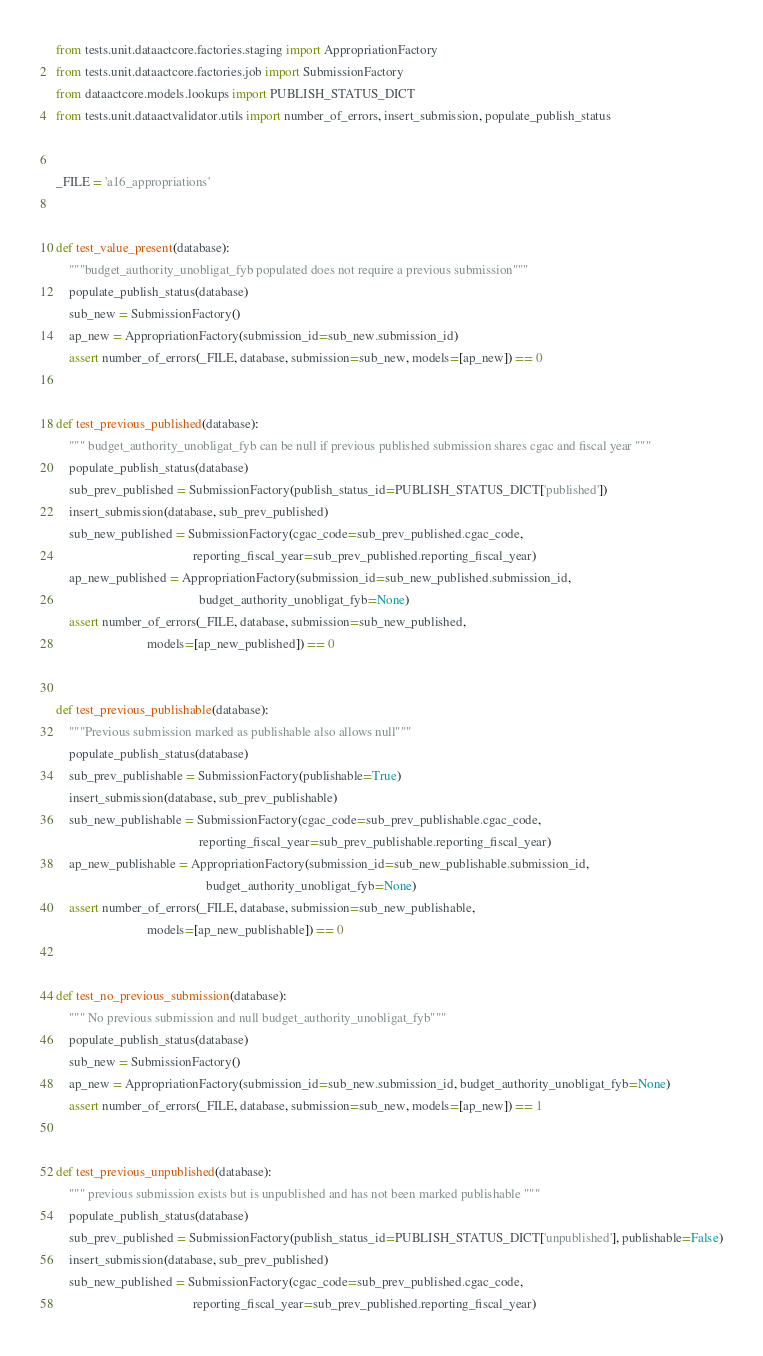<code> <loc_0><loc_0><loc_500><loc_500><_Python_>from tests.unit.dataactcore.factories.staging import AppropriationFactory
from tests.unit.dataactcore.factories.job import SubmissionFactory
from dataactcore.models.lookups import PUBLISH_STATUS_DICT
from tests.unit.dataactvalidator.utils import number_of_errors, insert_submission, populate_publish_status


_FILE = 'a16_appropriations'


def test_value_present(database):
    """budget_authority_unobligat_fyb populated does not require a previous submission"""
    populate_publish_status(database)
    sub_new = SubmissionFactory()
    ap_new = AppropriationFactory(submission_id=sub_new.submission_id)
    assert number_of_errors(_FILE, database, submission=sub_new, models=[ap_new]) == 0


def test_previous_published(database):
    """ budget_authority_unobligat_fyb can be null if previous published submission shares cgac and fiscal year """
    populate_publish_status(database)
    sub_prev_published = SubmissionFactory(publish_status_id=PUBLISH_STATUS_DICT['published'])
    insert_submission(database, sub_prev_published)
    sub_new_published = SubmissionFactory(cgac_code=sub_prev_published.cgac_code,
                                          reporting_fiscal_year=sub_prev_published.reporting_fiscal_year)
    ap_new_published = AppropriationFactory(submission_id=sub_new_published.submission_id,
                                            budget_authority_unobligat_fyb=None)
    assert number_of_errors(_FILE, database, submission=sub_new_published,
                            models=[ap_new_published]) == 0


def test_previous_publishable(database):
    """Previous submission marked as publishable also allows null"""
    populate_publish_status(database)
    sub_prev_publishable = SubmissionFactory(publishable=True)
    insert_submission(database, sub_prev_publishable)
    sub_new_publishable = SubmissionFactory(cgac_code=sub_prev_publishable.cgac_code,
                                            reporting_fiscal_year=sub_prev_publishable.reporting_fiscal_year)
    ap_new_publishable = AppropriationFactory(submission_id=sub_new_publishable.submission_id,
                                              budget_authority_unobligat_fyb=None)
    assert number_of_errors(_FILE, database, submission=sub_new_publishable,
                            models=[ap_new_publishable]) == 0


def test_no_previous_submission(database):
    """ No previous submission and null budget_authority_unobligat_fyb"""
    populate_publish_status(database)
    sub_new = SubmissionFactory()
    ap_new = AppropriationFactory(submission_id=sub_new.submission_id, budget_authority_unobligat_fyb=None)
    assert number_of_errors(_FILE, database, submission=sub_new, models=[ap_new]) == 1


def test_previous_unpublished(database):
    """ previous submission exists but is unpublished and has not been marked publishable """
    populate_publish_status(database)
    sub_prev_published = SubmissionFactory(publish_status_id=PUBLISH_STATUS_DICT['unpublished'], publishable=False)
    insert_submission(database, sub_prev_published)
    sub_new_published = SubmissionFactory(cgac_code=sub_prev_published.cgac_code,
                                          reporting_fiscal_year=sub_prev_published.reporting_fiscal_year)</code> 